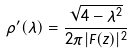Convert formula to latex. <formula><loc_0><loc_0><loc_500><loc_500>\rho ^ { \prime } ( \lambda ) = \frac { \sqrt { 4 - \lambda ^ { 2 } } } { 2 \pi | F ( z ) | ^ { 2 } }</formula> 